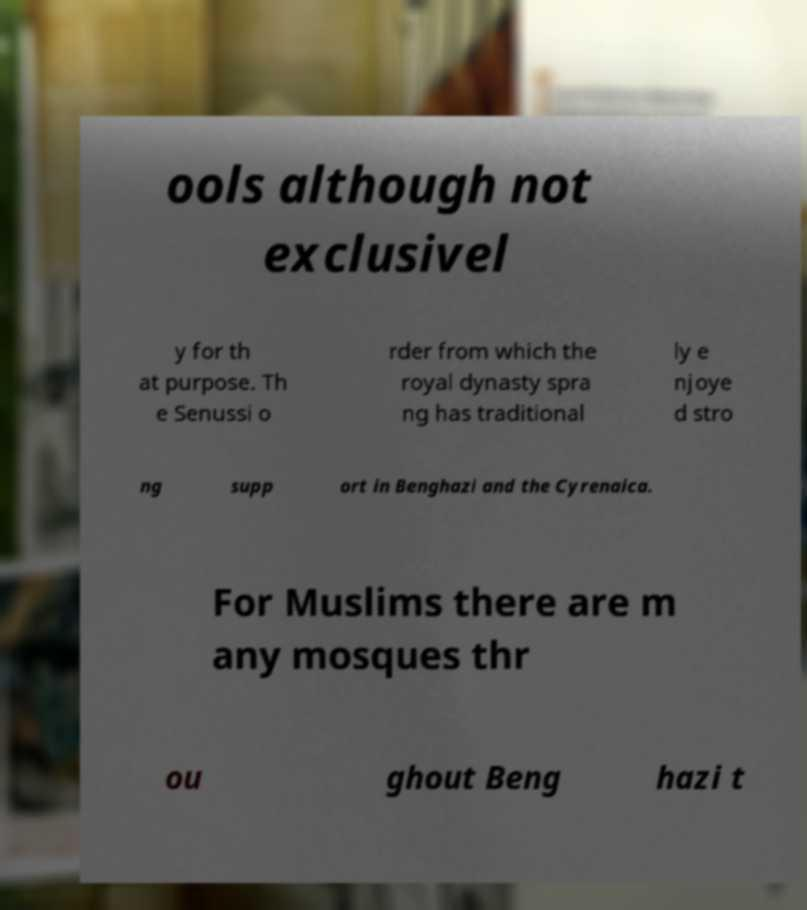Please identify and transcribe the text found in this image. ools although not exclusivel y for th at purpose. Th e Senussi o rder from which the royal dynasty spra ng has traditional ly e njoye d stro ng supp ort in Benghazi and the Cyrenaica. For Muslims there are m any mosques thr ou ghout Beng hazi t 